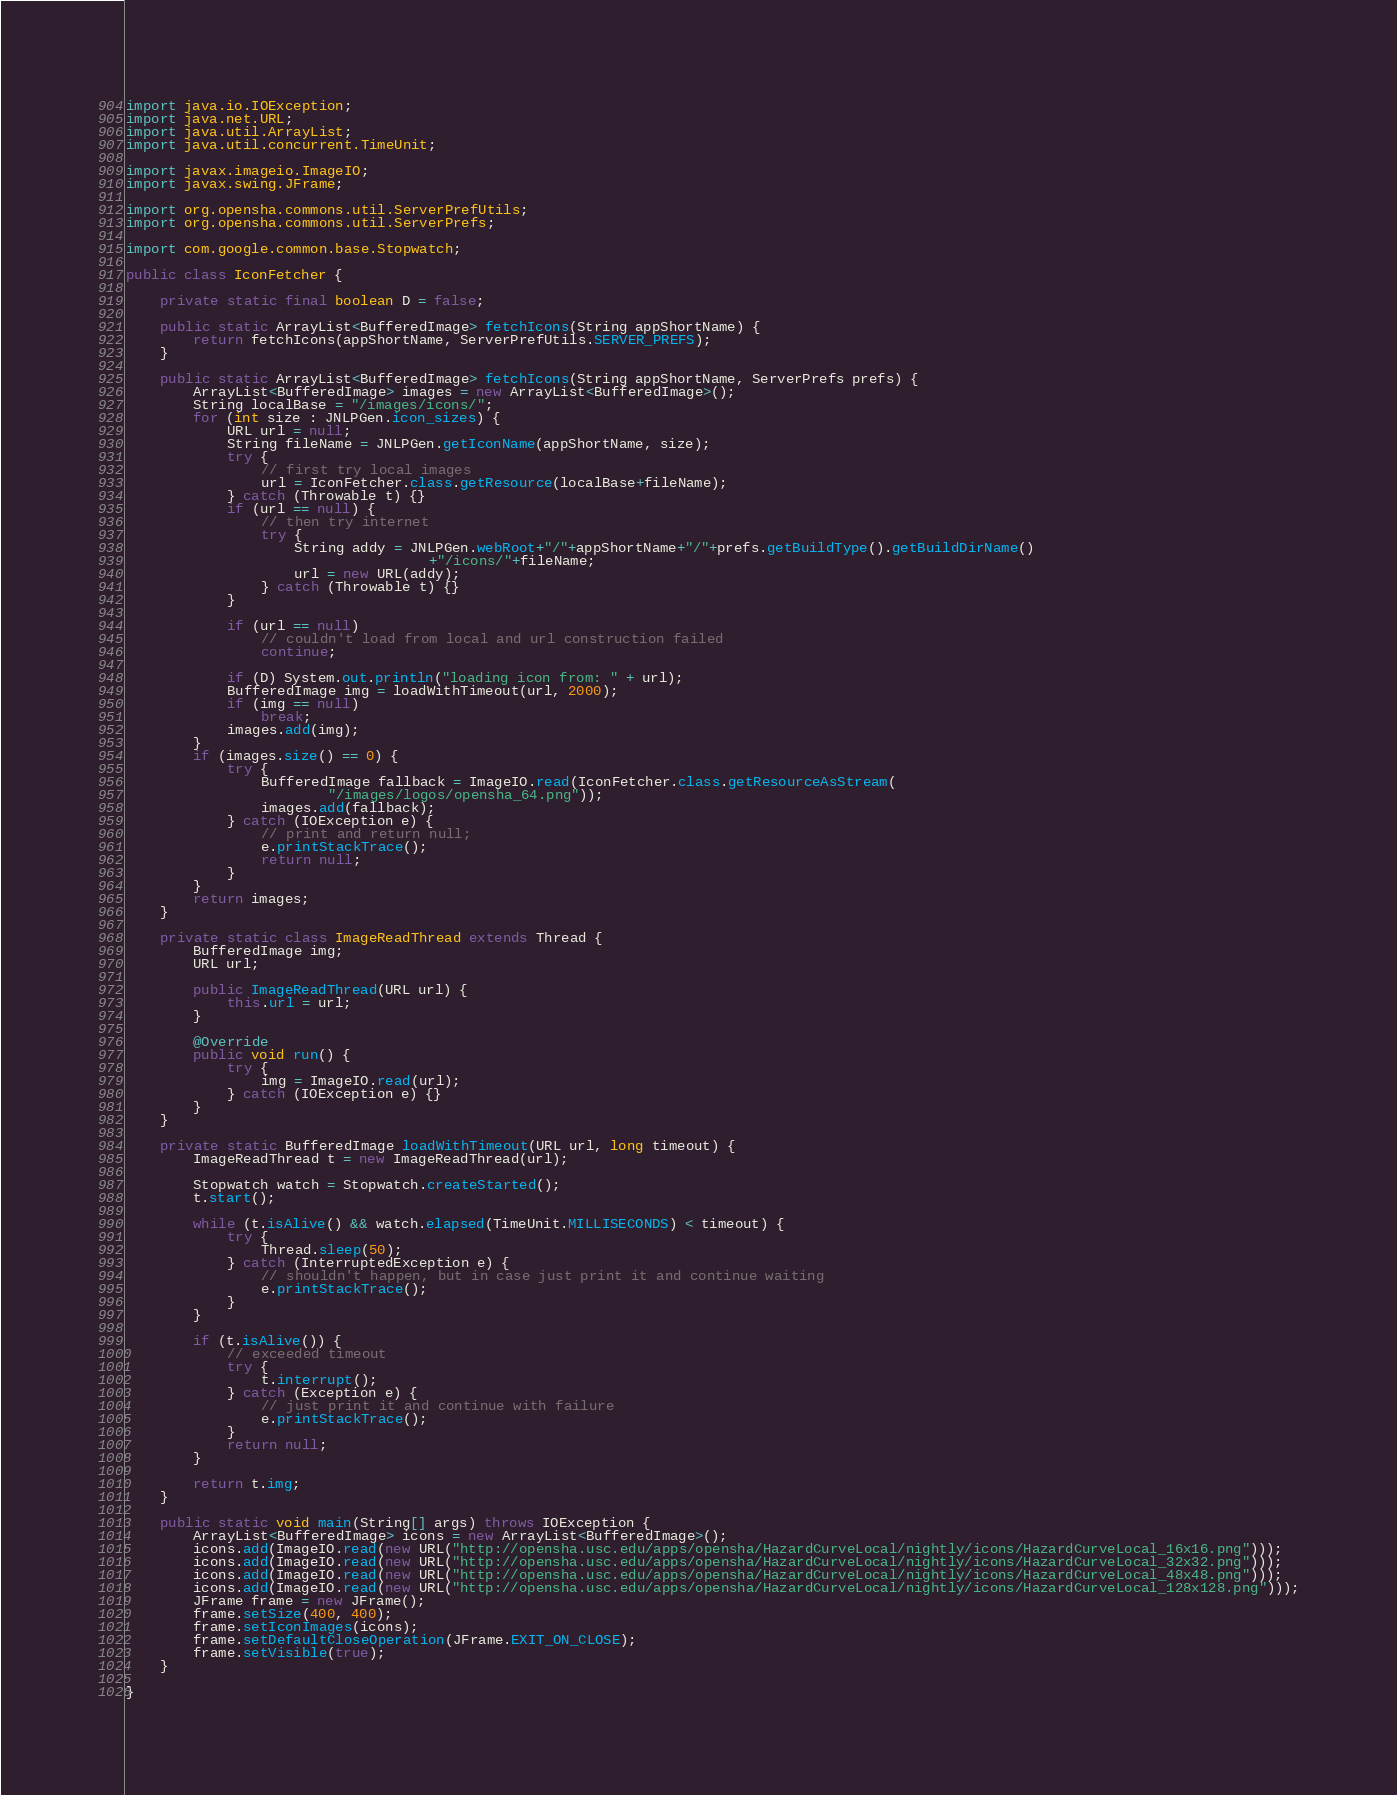Convert code to text. <code><loc_0><loc_0><loc_500><loc_500><_Java_>import java.io.IOException;
import java.net.URL;
import java.util.ArrayList;
import java.util.concurrent.TimeUnit;

import javax.imageio.ImageIO;
import javax.swing.JFrame;

import org.opensha.commons.util.ServerPrefUtils;
import org.opensha.commons.util.ServerPrefs;

import com.google.common.base.Stopwatch;

public class IconFetcher {
	
	private static final boolean D = false;
	
	public static ArrayList<BufferedImage> fetchIcons(String appShortName) {
		return fetchIcons(appShortName, ServerPrefUtils.SERVER_PREFS);
	}
	
	public static ArrayList<BufferedImage> fetchIcons(String appShortName, ServerPrefs prefs) {
		ArrayList<BufferedImage> images = new ArrayList<BufferedImage>();
		String localBase = "/images/icons/";
		for (int size : JNLPGen.icon_sizes) {
			URL url = null;
			String fileName = JNLPGen.getIconName(appShortName, size);
			try {
				// first try local images
				url = IconFetcher.class.getResource(localBase+fileName);
			} catch (Throwable t) {}
			if (url == null) {
				// then try internet
				try {
					String addy = JNLPGen.webRoot+"/"+appShortName+"/"+prefs.getBuildType().getBuildDirName()
									+"/icons/"+fileName;
					url = new URL(addy);
				} catch (Throwable t) {}
			}
			
			if (url == null)
				// couldn't load from local and url construction failed
				continue;
			
			if (D) System.out.println("loading icon from: " + url);
			BufferedImage img = loadWithTimeout(url, 2000);
			if (img == null)
				break;
			images.add(img);
		}
		if (images.size() == 0) {
			try {
				BufferedImage fallback = ImageIO.read(IconFetcher.class.getResourceAsStream(
						"/images/logos/opensha_64.png"));
				images.add(fallback);
			} catch (IOException e) {
				// print and return null;
				e.printStackTrace();
				return null;
			}
		}
		return images;
	}
	
	private static class ImageReadThread extends Thread {
		BufferedImage img;
		URL url;
		
		public ImageReadThread(URL url) {
			this.url = url;
		}
		
		@Override
		public void run() {
			try {
				img = ImageIO.read(url);
			} catch (IOException e) {}
		}
	}
	
	private static BufferedImage loadWithTimeout(URL url, long timeout) {
		ImageReadThread t = new ImageReadThread(url);
		
		Stopwatch watch = Stopwatch.createStarted();
		t.start();
		
		while (t.isAlive() && watch.elapsed(TimeUnit.MILLISECONDS) < timeout) {
			try {
				Thread.sleep(50);
			} catch (InterruptedException e) {
				// shouldn't happen, but in case just print it and continue waiting
				e.printStackTrace();
			}
		}
		
		if (t.isAlive()) {
			// exceeded timeout
			try {
				t.interrupt();
			} catch (Exception e) {
				// just print it and continue with failure
				e.printStackTrace();
			}
			return null;
		}
		
		return t.img;
	}
	
	public static void main(String[] args) throws IOException {
		ArrayList<BufferedImage> icons = new ArrayList<BufferedImage>();
		icons.add(ImageIO.read(new URL("http://opensha.usc.edu/apps/opensha/HazardCurveLocal/nightly/icons/HazardCurveLocal_16x16.png")));
		icons.add(ImageIO.read(new URL("http://opensha.usc.edu/apps/opensha/HazardCurveLocal/nightly/icons/HazardCurveLocal_32x32.png")));
		icons.add(ImageIO.read(new URL("http://opensha.usc.edu/apps/opensha/HazardCurveLocal/nightly/icons/HazardCurveLocal_48x48.png")));
		icons.add(ImageIO.read(new URL("http://opensha.usc.edu/apps/opensha/HazardCurveLocal/nightly/icons/HazardCurveLocal_128x128.png")));
		JFrame frame = new JFrame();
		frame.setSize(400, 400);
		frame.setIconImages(icons);
		frame.setDefaultCloseOperation(JFrame.EXIT_ON_CLOSE);
		frame.setVisible(true);
	}

}
</code> 